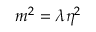Convert formula to latex. <formula><loc_0><loc_0><loc_500><loc_500>m ^ { 2 } = \lambda \eta ^ { 2 }</formula> 